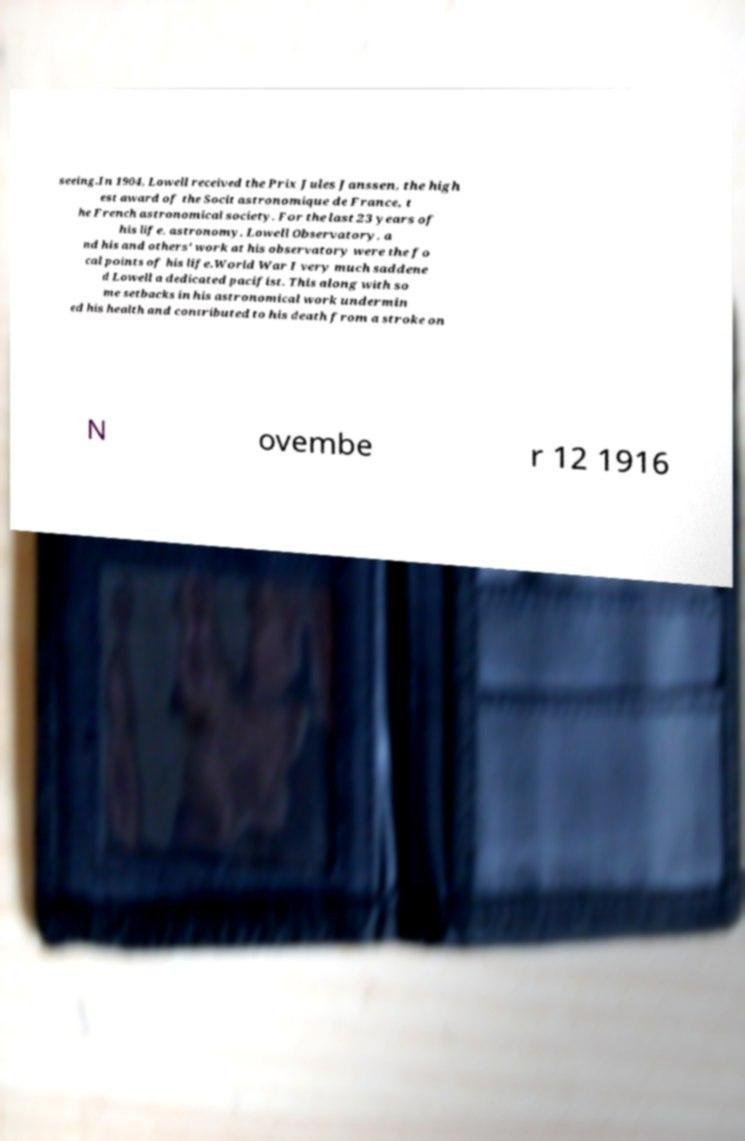What messages or text are displayed in this image? I need them in a readable, typed format. seeing.In 1904, Lowell received the Prix Jules Janssen, the high est award of the Socit astronomique de France, t he French astronomical society. For the last 23 years of his life, astronomy, Lowell Observatory, a nd his and others' work at his observatory were the fo cal points of his life.World War I very much saddene d Lowell a dedicated pacifist. This along with so me setbacks in his astronomical work undermin ed his health and contributed to his death from a stroke on N ovembe r 12 1916 